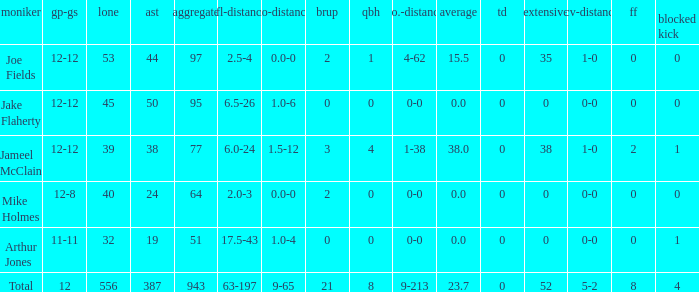What is the total brup for the team? 21.0. Give me the full table as a dictionary. {'header': ['moniker', 'gp-gs', 'lone', 'ast', 'aggregate', 'tfl-distance', 'no-distance', 'brup', 'qbh', 'no.-distance', 'average', 'td', 'extensive', 'rcv-distance', 'ff', 'blocked kick'], 'rows': [['Joe Fields', '12-12', '53', '44', '97', '2.5-4', '0.0-0', '2', '1', '4-62', '15.5', '0', '35', '1-0', '0', '0'], ['Jake Flaherty', '12-12', '45', '50', '95', '6.5-26', '1.0-6', '0', '0', '0-0', '0.0', '0', '0', '0-0', '0', '0'], ['Jameel McClain', '12-12', '39', '38', '77', '6.0-24', '1.5-12', '3', '4', '1-38', '38.0', '0', '38', '1-0', '2', '1'], ['Mike Holmes', '12-8', '40', '24', '64', '2.0-3', '0.0-0', '2', '0', '0-0', '0.0', '0', '0', '0-0', '0', '0'], ['Arthur Jones', '11-11', '32', '19', '51', '17.5-43', '1.0-4', '0', '0', '0-0', '0.0', '0', '0', '0-0', '0', '1'], ['Total', '12', '556', '387', '943', '63-197', '9-65', '21', '8', '9-213', '23.7', '0', '52', '5-2', '8', '4']]} 